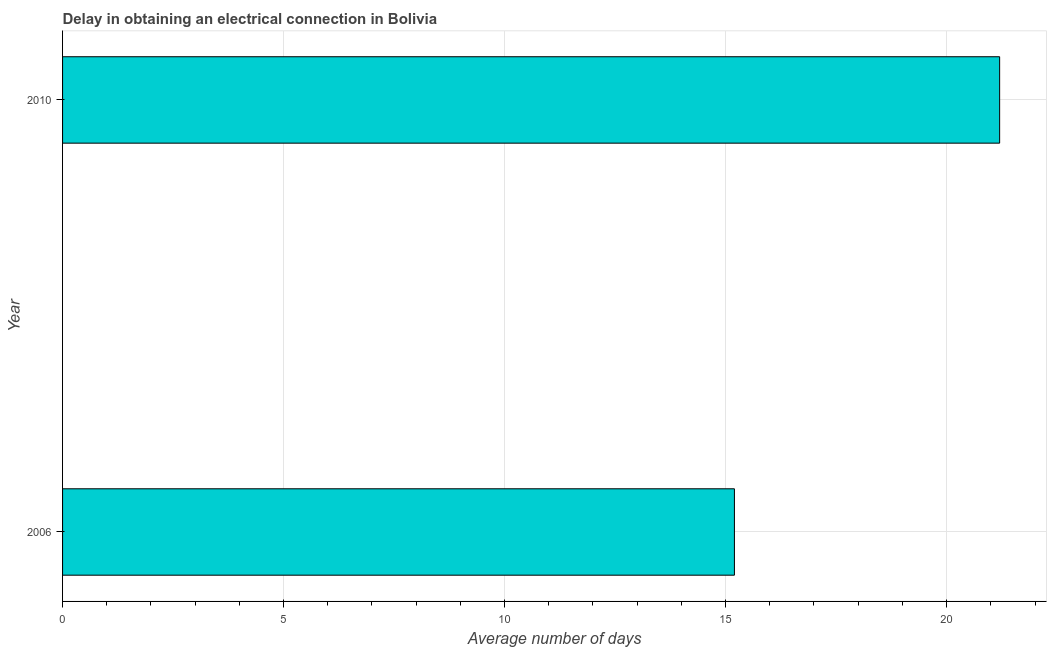Does the graph contain any zero values?
Ensure brevity in your answer.  No. Does the graph contain grids?
Give a very brief answer. Yes. What is the title of the graph?
Offer a very short reply. Delay in obtaining an electrical connection in Bolivia. What is the label or title of the X-axis?
Your answer should be very brief. Average number of days. What is the dalay in electrical connection in 2010?
Provide a succinct answer. 21.2. Across all years, what is the maximum dalay in electrical connection?
Offer a terse response. 21.2. Across all years, what is the minimum dalay in electrical connection?
Provide a short and direct response. 15.2. In which year was the dalay in electrical connection maximum?
Offer a very short reply. 2010. In which year was the dalay in electrical connection minimum?
Your answer should be compact. 2006. What is the sum of the dalay in electrical connection?
Offer a very short reply. 36.4. What is the difference between the dalay in electrical connection in 2006 and 2010?
Your response must be concise. -6. What is the average dalay in electrical connection per year?
Your answer should be very brief. 18.2. Do a majority of the years between 2006 and 2010 (inclusive) have dalay in electrical connection greater than 11 days?
Your answer should be very brief. Yes. What is the ratio of the dalay in electrical connection in 2006 to that in 2010?
Your answer should be very brief. 0.72. Is the dalay in electrical connection in 2006 less than that in 2010?
Ensure brevity in your answer.  Yes. How many bars are there?
Ensure brevity in your answer.  2. How many years are there in the graph?
Offer a terse response. 2. What is the difference between two consecutive major ticks on the X-axis?
Ensure brevity in your answer.  5. Are the values on the major ticks of X-axis written in scientific E-notation?
Ensure brevity in your answer.  No. What is the Average number of days of 2006?
Make the answer very short. 15.2. What is the Average number of days of 2010?
Make the answer very short. 21.2. What is the ratio of the Average number of days in 2006 to that in 2010?
Provide a succinct answer. 0.72. 